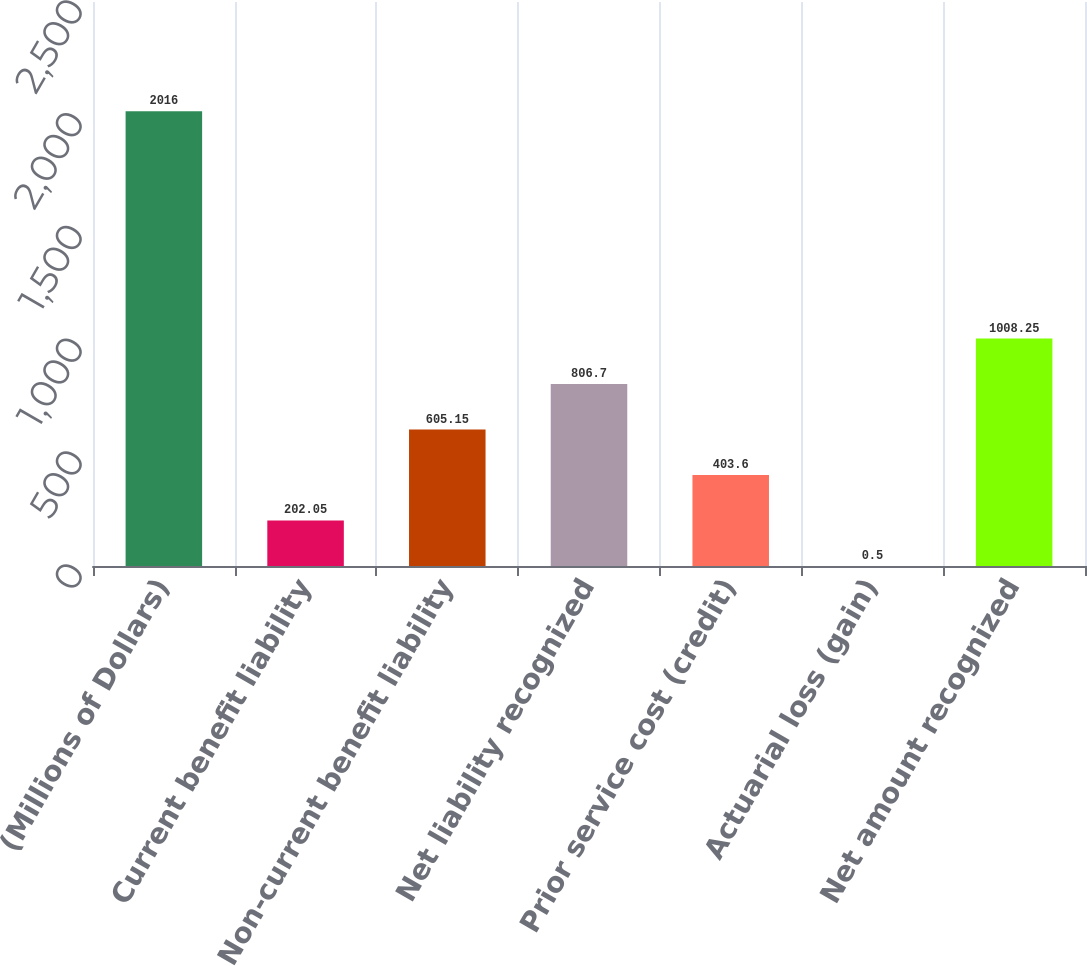Convert chart to OTSL. <chart><loc_0><loc_0><loc_500><loc_500><bar_chart><fcel>(Millions of Dollars)<fcel>Current benefit liability<fcel>Non-current benefit liability<fcel>Net liability recognized<fcel>Prior service cost (credit)<fcel>Actuarial loss (gain)<fcel>Net amount recognized<nl><fcel>2016<fcel>202.05<fcel>605.15<fcel>806.7<fcel>403.6<fcel>0.5<fcel>1008.25<nl></chart> 